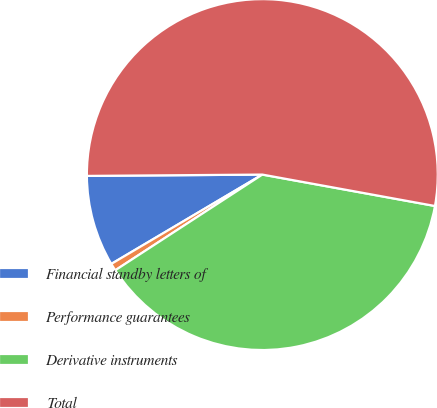Convert chart to OTSL. <chart><loc_0><loc_0><loc_500><loc_500><pie_chart><fcel>Financial standby letters of<fcel>Performance guarantees<fcel>Derivative instruments<fcel>Total<nl><fcel>8.38%<fcel>0.68%<fcel>37.95%<fcel>52.98%<nl></chart> 